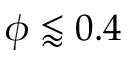Convert formula to latex. <formula><loc_0><loc_0><loc_500><loc_500>\phi \lessapprox 0 . 4</formula> 